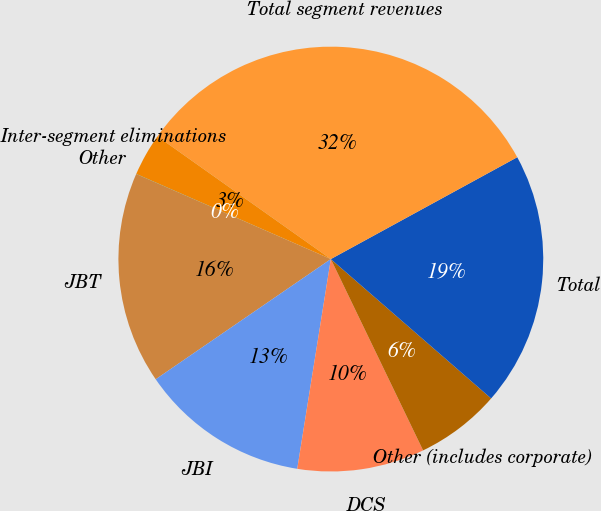<chart> <loc_0><loc_0><loc_500><loc_500><pie_chart><fcel>JBT<fcel>JBI<fcel>DCS<fcel>Other (includes corporate)<fcel>Total<fcel>Total segment revenues<fcel>Inter-segment eliminations<fcel>Other<nl><fcel>16.13%<fcel>12.9%<fcel>9.68%<fcel>6.46%<fcel>19.35%<fcel>32.24%<fcel>3.24%<fcel>0.01%<nl></chart> 